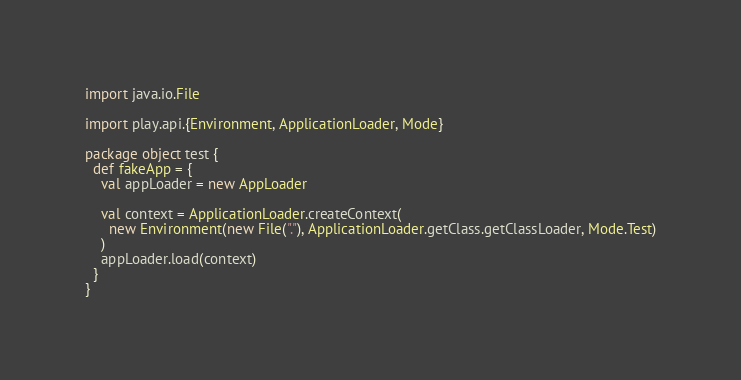Convert code to text. <code><loc_0><loc_0><loc_500><loc_500><_Scala_>import java.io.File

import play.api.{Environment, ApplicationLoader, Mode}

package object test {
  def fakeApp = {
    val appLoader = new AppLoader

    val context = ApplicationLoader.createContext(
      new Environment(new File("."), ApplicationLoader.getClass.getClassLoader, Mode.Test)
    )
    appLoader.load(context)
  }
}
</code> 